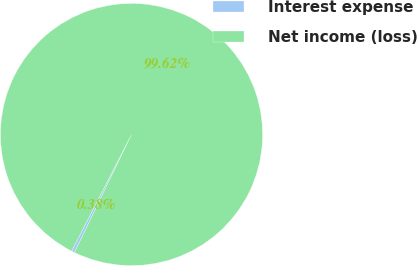<chart> <loc_0><loc_0><loc_500><loc_500><pie_chart><fcel>Interest expense<fcel>Net income (loss)<nl><fcel>0.38%<fcel>99.62%<nl></chart> 